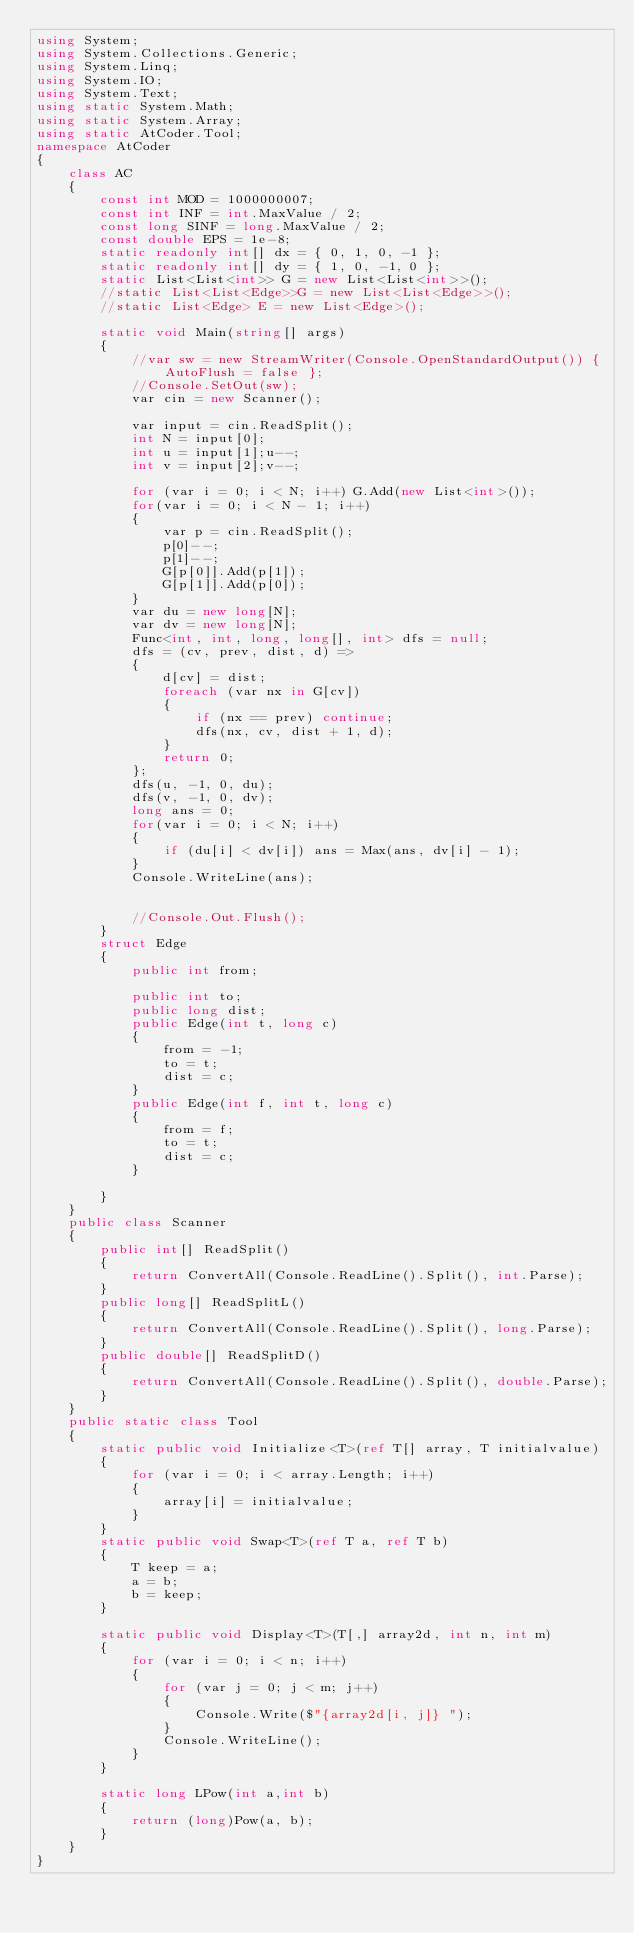Convert code to text. <code><loc_0><loc_0><loc_500><loc_500><_C#_>using System;
using System.Collections.Generic;
using System.Linq;
using System.IO;
using System.Text;
using static System.Math;
using static System.Array;
using static AtCoder.Tool;
namespace AtCoder
{
    class AC
    {
        const int MOD = 1000000007;
        const int INF = int.MaxValue / 2;
        const long SINF = long.MaxValue / 2;
        const double EPS = 1e-8;
        static readonly int[] dx = { 0, 1, 0, -1 };
        static readonly int[] dy = { 1, 0, -1, 0 };
        static List<List<int>> G = new List<List<int>>();
        //static List<List<Edge>>G = new List<List<Edge>>();
        //static List<Edge> E = new List<Edge>();
        
        static void Main(string[] args)
        {
            //var sw = new StreamWriter(Console.OpenStandardOutput()) { AutoFlush = false };
            //Console.SetOut(sw);
            var cin = new Scanner();

            var input = cin.ReadSplit();
            int N = input[0];
            int u = input[1];u--;
            int v = input[2];v--;

            for (var i = 0; i < N; i++) G.Add(new List<int>());
            for(var i = 0; i < N - 1; i++)
            {
                var p = cin.ReadSplit();
                p[0]--;
                p[1]--;
                G[p[0]].Add(p[1]);
                G[p[1]].Add(p[0]);
            }
            var du = new long[N];
            var dv = new long[N];
            Func<int, int, long, long[], int> dfs = null;
            dfs = (cv, prev, dist, d) =>
            {
                d[cv] = dist;
                foreach (var nx in G[cv])
                {
                    if (nx == prev) continue;
                    dfs(nx, cv, dist + 1, d);
                }
                return 0;
            };
            dfs(u, -1, 0, du);
            dfs(v, -1, 0, dv);
            long ans = 0;
            for(var i = 0; i < N; i++)
            {
                if (du[i] < dv[i]) ans = Max(ans, dv[i] - 1);
            }
            Console.WriteLine(ans);


            //Console.Out.Flush();
        }
        struct Edge
        {
            public int from;

            public int to;
            public long dist;
            public Edge(int t, long c)
            {
                from = -1;
                to = t;
                dist = c;
            }
            public Edge(int f, int t, long c)
            {
                from = f;
                to = t;
                dist = c;
            }

        }
    }
    public class Scanner
    {
        public int[] ReadSplit()
        {
            return ConvertAll(Console.ReadLine().Split(), int.Parse);
        }
        public long[] ReadSplitL()
        {
            return ConvertAll(Console.ReadLine().Split(), long.Parse);
        }
        public double[] ReadSplitD()
        {
            return ConvertAll(Console.ReadLine().Split(), double.Parse);
        }
    }
    public static class Tool
    {
        static public void Initialize<T>(ref T[] array, T initialvalue)
        {
            for (var i = 0; i < array.Length; i++)
            {
                array[i] = initialvalue;
            }
        }
        static public void Swap<T>(ref T a, ref T b)
        {
            T keep = a;
            a = b;
            b = keep;
        }

        static public void Display<T>(T[,] array2d, int n, int m)
        {
            for (var i = 0; i < n; i++)
            {
                for (var j = 0; j < m; j++)
                {
                    Console.Write($"{array2d[i, j]} ");
                }
                Console.WriteLine();
            }
        }

        static long LPow(int a,int b)
        {
            return (long)Pow(a, b);
        }
    }
}
</code> 